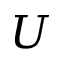<formula> <loc_0><loc_0><loc_500><loc_500>U</formula> 